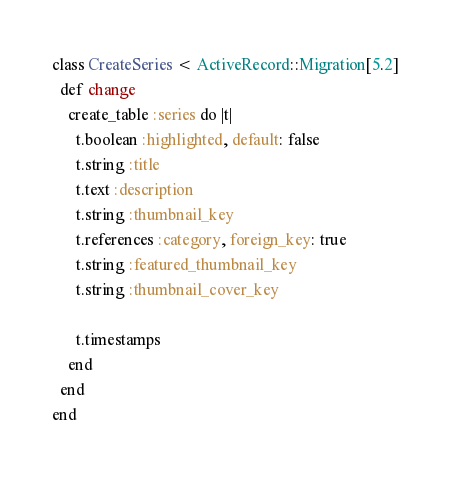Convert code to text. <code><loc_0><loc_0><loc_500><loc_500><_Ruby_>class CreateSeries < ActiveRecord::Migration[5.2]
  def change
    create_table :series do |t|
      t.boolean :highlighted, default: false
      t.string :title
      t.text :description
      t.string :thumbnail_key
      t.references :category, foreign_key: true
      t.string :featured_thumbnail_key
      t.string :thumbnail_cover_key

      t.timestamps
    end
  end
end</code> 